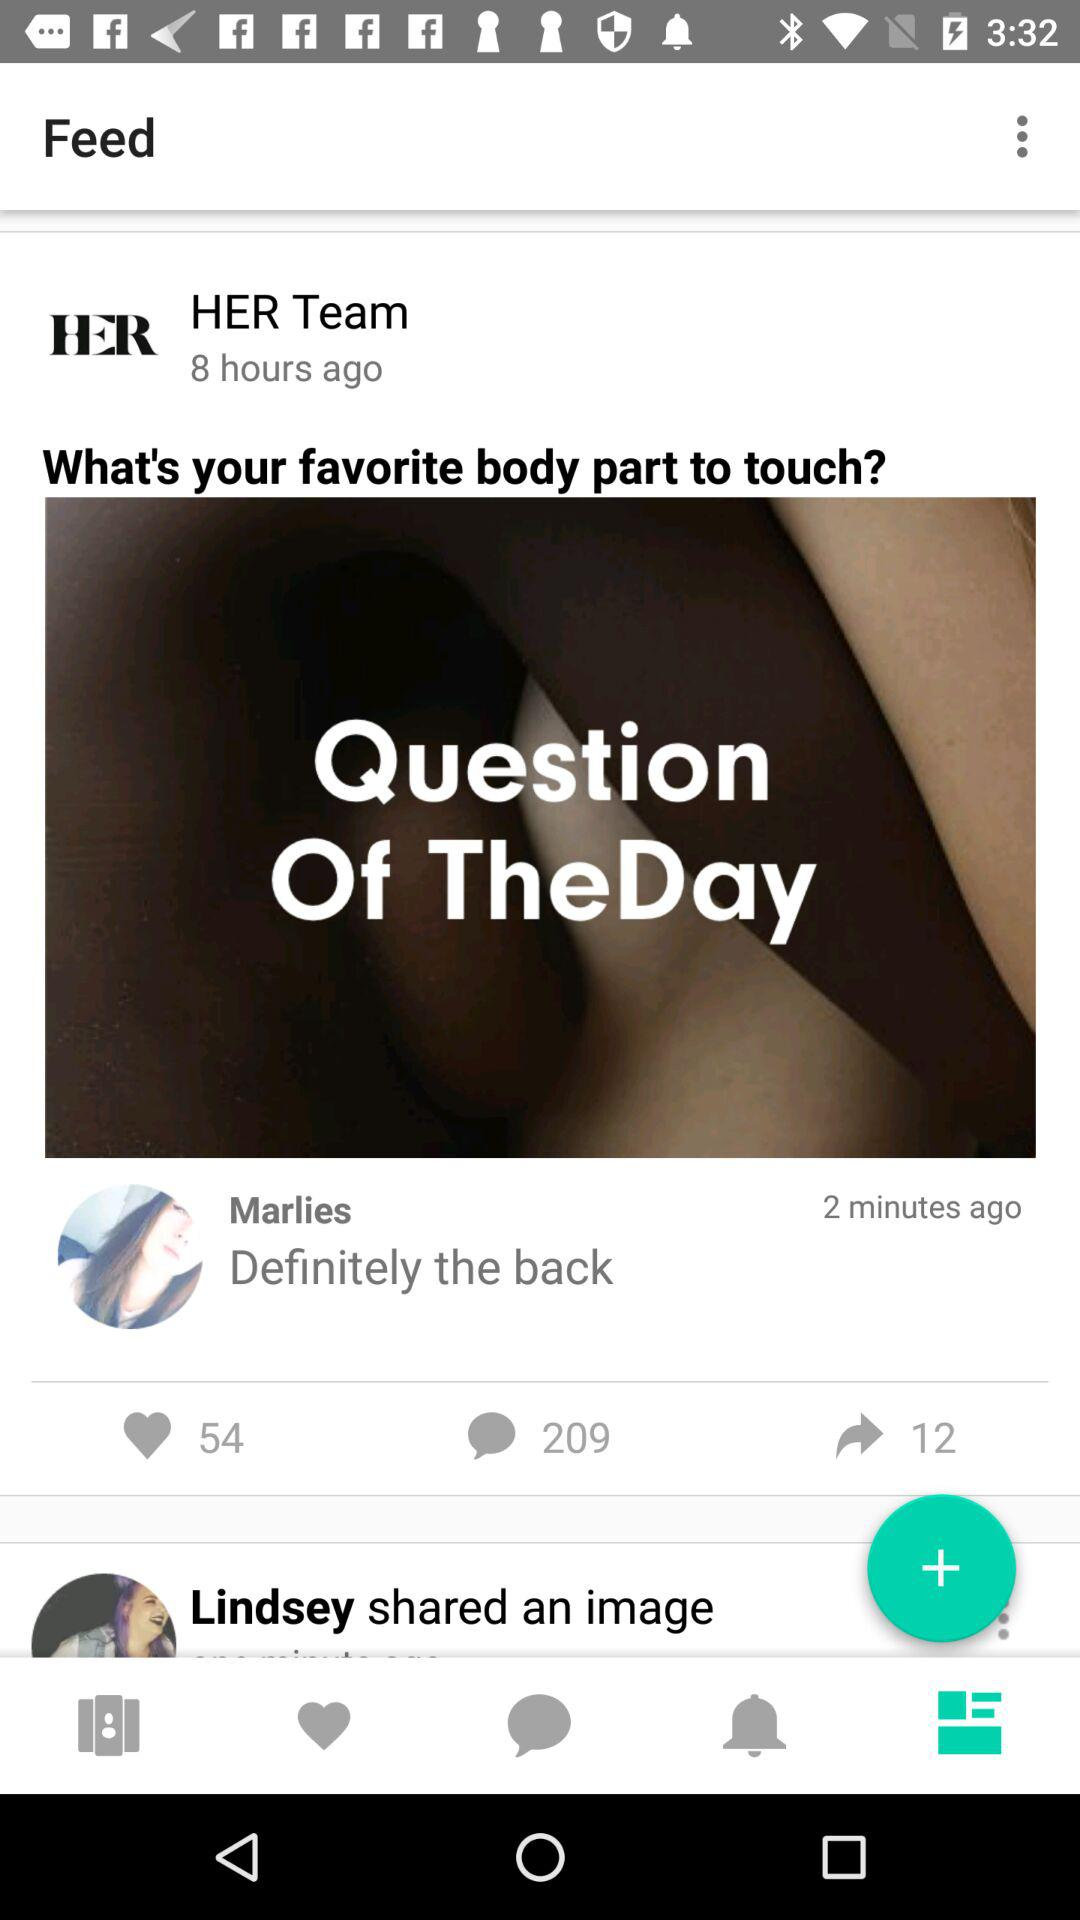When was the post posted? The post was posted 8 hours ago. 